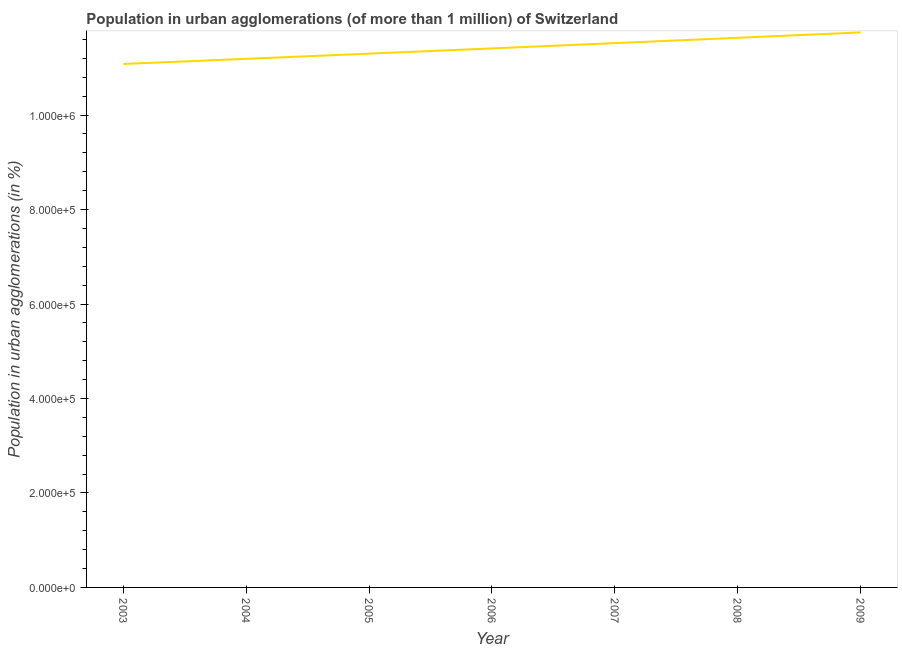What is the population in urban agglomerations in 2004?
Make the answer very short. 1.12e+06. Across all years, what is the maximum population in urban agglomerations?
Ensure brevity in your answer.  1.17e+06. Across all years, what is the minimum population in urban agglomerations?
Provide a short and direct response. 1.11e+06. What is the sum of the population in urban agglomerations?
Make the answer very short. 7.99e+06. What is the difference between the population in urban agglomerations in 2003 and 2005?
Provide a succinct answer. -2.18e+04. What is the average population in urban agglomerations per year?
Offer a very short reply. 1.14e+06. What is the median population in urban agglomerations?
Give a very brief answer. 1.14e+06. What is the ratio of the population in urban agglomerations in 2005 to that in 2007?
Provide a short and direct response. 0.98. What is the difference between the highest and the second highest population in urban agglomerations?
Your answer should be very brief. 1.14e+04. Is the sum of the population in urban agglomerations in 2003 and 2008 greater than the maximum population in urban agglomerations across all years?
Provide a short and direct response. Yes. What is the difference between the highest and the lowest population in urban agglomerations?
Provide a succinct answer. 6.68e+04. How many years are there in the graph?
Your answer should be compact. 7. Are the values on the major ticks of Y-axis written in scientific E-notation?
Your answer should be compact. Yes. Does the graph contain any zero values?
Offer a very short reply. No. What is the title of the graph?
Offer a very short reply. Population in urban agglomerations (of more than 1 million) of Switzerland. What is the label or title of the Y-axis?
Give a very brief answer. Population in urban agglomerations (in %). What is the Population in urban agglomerations (in %) of 2003?
Offer a terse response. 1.11e+06. What is the Population in urban agglomerations (in %) of 2004?
Keep it short and to the point. 1.12e+06. What is the Population in urban agglomerations (in %) of 2005?
Offer a terse response. 1.13e+06. What is the Population in urban agglomerations (in %) of 2006?
Your answer should be compact. 1.14e+06. What is the Population in urban agglomerations (in %) of 2007?
Your response must be concise. 1.15e+06. What is the Population in urban agglomerations (in %) of 2008?
Your answer should be compact. 1.16e+06. What is the Population in urban agglomerations (in %) of 2009?
Offer a very short reply. 1.17e+06. What is the difference between the Population in urban agglomerations (in %) in 2003 and 2004?
Provide a succinct answer. -1.09e+04. What is the difference between the Population in urban agglomerations (in %) in 2003 and 2005?
Give a very brief answer. -2.18e+04. What is the difference between the Population in urban agglomerations (in %) in 2003 and 2006?
Keep it short and to the point. -3.29e+04. What is the difference between the Population in urban agglomerations (in %) in 2003 and 2007?
Make the answer very short. -4.41e+04. What is the difference between the Population in urban agglomerations (in %) in 2003 and 2008?
Offer a very short reply. -5.54e+04. What is the difference between the Population in urban agglomerations (in %) in 2003 and 2009?
Ensure brevity in your answer.  -6.68e+04. What is the difference between the Population in urban agglomerations (in %) in 2004 and 2005?
Your answer should be very brief. -1.10e+04. What is the difference between the Population in urban agglomerations (in %) in 2004 and 2006?
Your answer should be compact. -2.20e+04. What is the difference between the Population in urban agglomerations (in %) in 2004 and 2007?
Give a very brief answer. -3.32e+04. What is the difference between the Population in urban agglomerations (in %) in 2004 and 2008?
Your answer should be compact. -4.45e+04. What is the difference between the Population in urban agglomerations (in %) in 2004 and 2009?
Provide a short and direct response. -5.59e+04. What is the difference between the Population in urban agglomerations (in %) in 2005 and 2006?
Keep it short and to the point. -1.11e+04. What is the difference between the Population in urban agglomerations (in %) in 2005 and 2007?
Provide a succinct answer. -2.23e+04. What is the difference between the Population in urban agglomerations (in %) in 2005 and 2008?
Your answer should be compact. -3.36e+04. What is the difference between the Population in urban agglomerations (in %) in 2005 and 2009?
Ensure brevity in your answer.  -4.50e+04. What is the difference between the Population in urban agglomerations (in %) in 2006 and 2007?
Ensure brevity in your answer.  -1.12e+04. What is the difference between the Population in urban agglomerations (in %) in 2006 and 2008?
Your response must be concise. -2.25e+04. What is the difference between the Population in urban agglomerations (in %) in 2006 and 2009?
Give a very brief answer. -3.39e+04. What is the difference between the Population in urban agglomerations (in %) in 2007 and 2008?
Keep it short and to the point. -1.13e+04. What is the difference between the Population in urban agglomerations (in %) in 2007 and 2009?
Make the answer very short. -2.27e+04. What is the difference between the Population in urban agglomerations (in %) in 2008 and 2009?
Keep it short and to the point. -1.14e+04. What is the ratio of the Population in urban agglomerations (in %) in 2003 to that in 2005?
Offer a terse response. 0.98. What is the ratio of the Population in urban agglomerations (in %) in 2003 to that in 2007?
Make the answer very short. 0.96. What is the ratio of the Population in urban agglomerations (in %) in 2003 to that in 2008?
Offer a terse response. 0.95. What is the ratio of the Population in urban agglomerations (in %) in 2003 to that in 2009?
Your response must be concise. 0.94. What is the ratio of the Population in urban agglomerations (in %) in 2005 to that in 2008?
Your answer should be very brief. 0.97. What is the ratio of the Population in urban agglomerations (in %) in 2005 to that in 2009?
Keep it short and to the point. 0.96. What is the ratio of the Population in urban agglomerations (in %) in 2006 to that in 2008?
Give a very brief answer. 0.98. What is the ratio of the Population in urban agglomerations (in %) in 2006 to that in 2009?
Make the answer very short. 0.97. What is the ratio of the Population in urban agglomerations (in %) in 2007 to that in 2008?
Your answer should be compact. 0.99. What is the ratio of the Population in urban agglomerations (in %) in 2007 to that in 2009?
Your answer should be very brief. 0.98. 